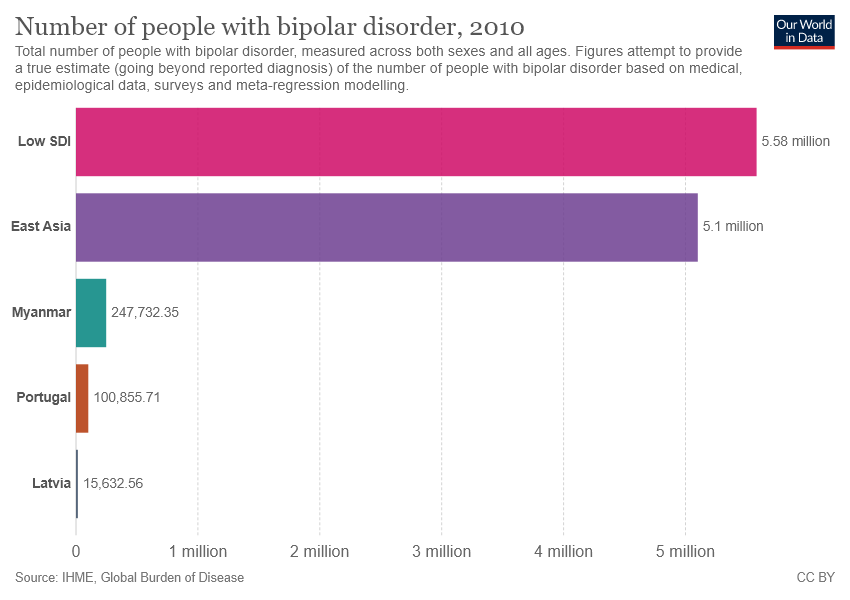Specify some key components in this picture. The difference between the largest bar and the second largest bar is 0.48. The value of the green bar is 247,732.35. 